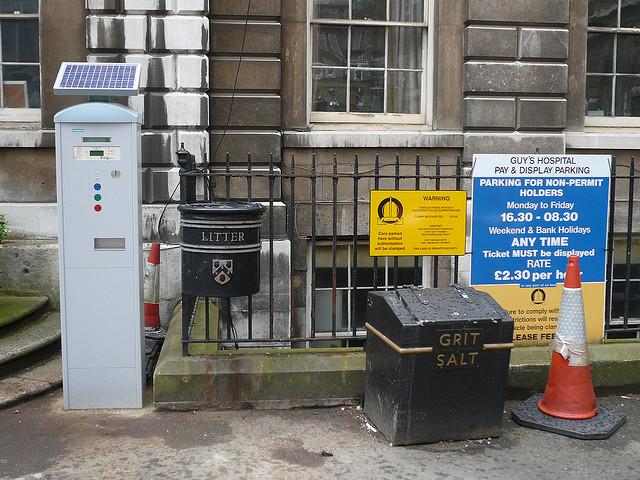Does the sign give information about parking?
Give a very brief answer. Yes. What is on the ground by the windows?
Give a very brief answer. Salt. What is in the black container?
Keep it brief. Grit salt. What is orange and white in the picture?
Short answer required. Cone. 